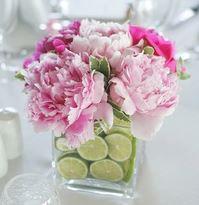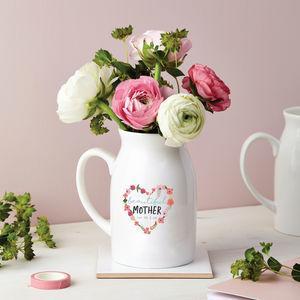The first image is the image on the left, the second image is the image on the right. Examine the images to the left and right. Is the description "A bunch of green stems are visible through the glass in the vase on the right." accurate? Answer yes or no. No. 